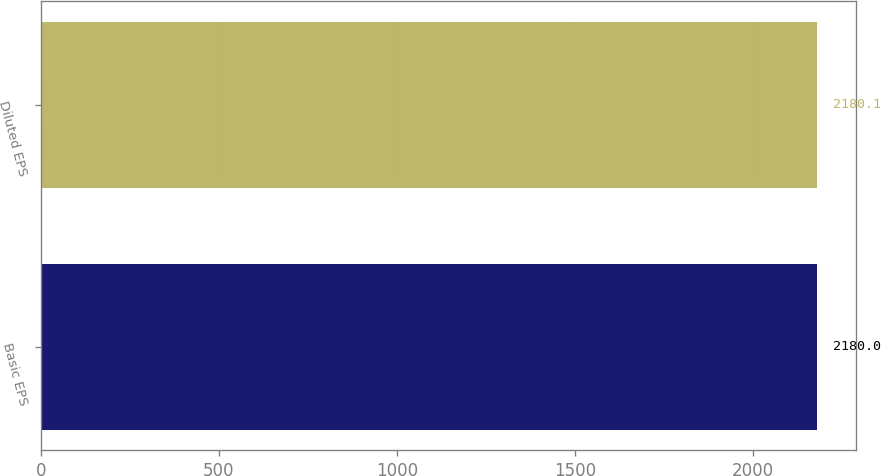Convert chart. <chart><loc_0><loc_0><loc_500><loc_500><bar_chart><fcel>Basic EPS<fcel>Diluted EPS<nl><fcel>2180<fcel>2180.1<nl></chart> 